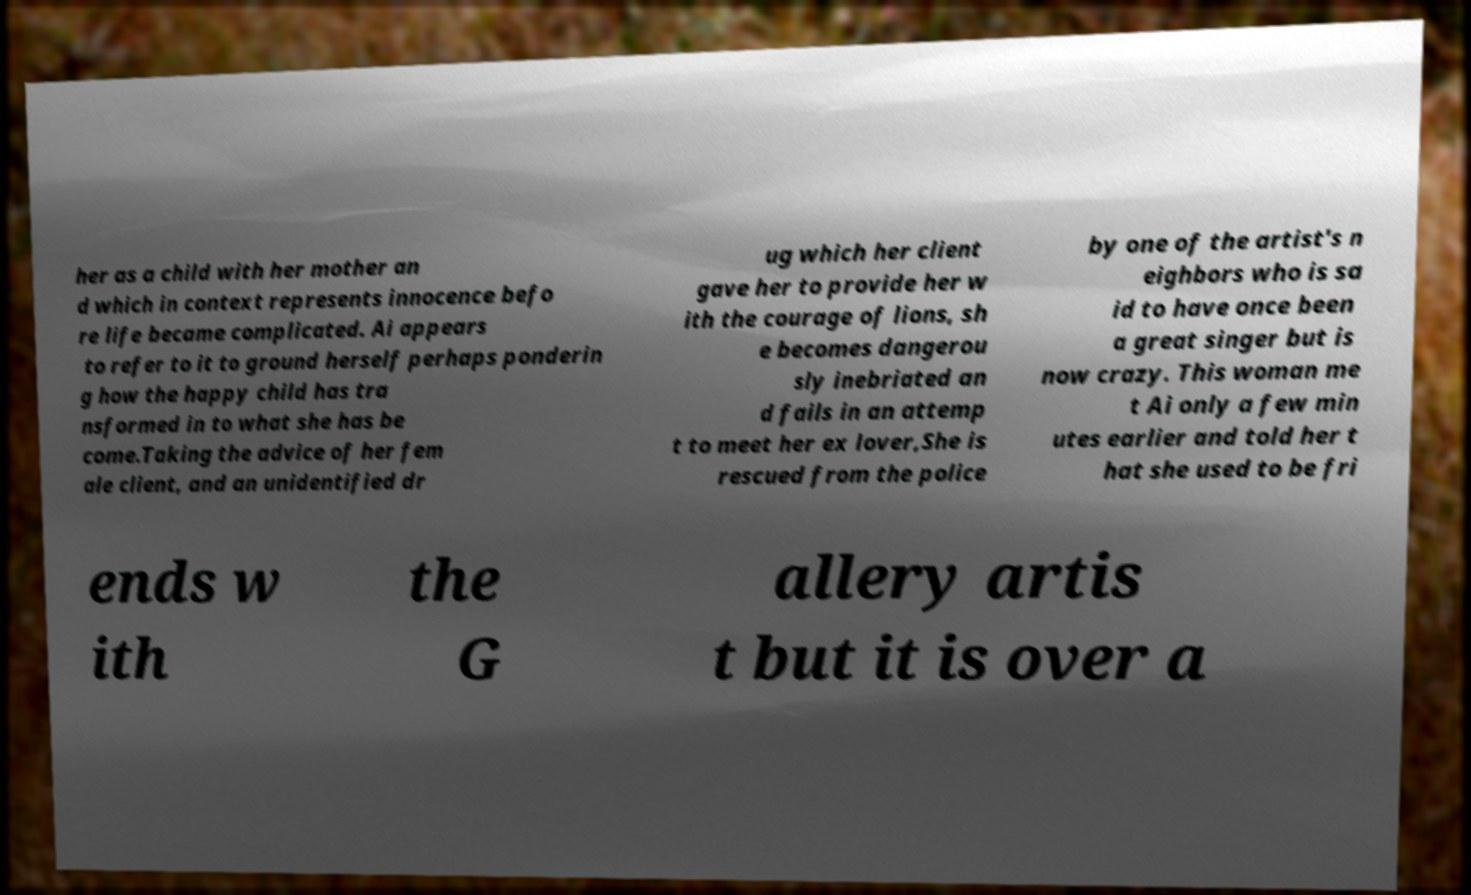Please identify and transcribe the text found in this image. her as a child with her mother an d which in context represents innocence befo re life became complicated. Ai appears to refer to it to ground herself perhaps ponderin g how the happy child has tra nsformed in to what she has be come.Taking the advice of her fem ale client, and an unidentified dr ug which her client gave her to provide her w ith the courage of lions, sh e becomes dangerou sly inebriated an d fails in an attemp t to meet her ex lover,She is rescued from the police by one of the artist's n eighbors who is sa id to have once been a great singer but is now crazy. This woman me t Ai only a few min utes earlier and told her t hat she used to be fri ends w ith the G allery artis t but it is over a 